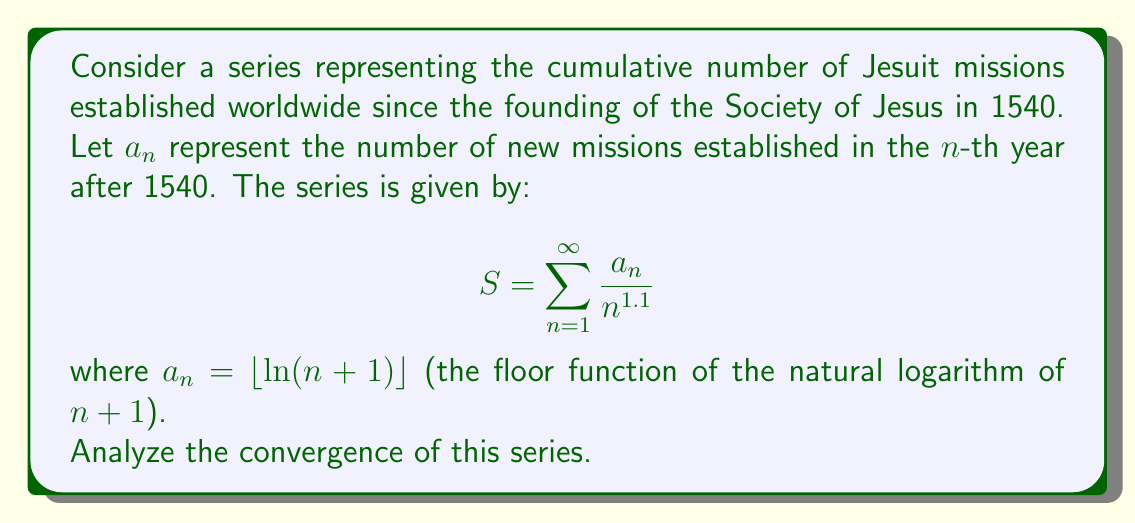Can you answer this question? To analyze the convergence of this series, we'll use the limit comparison test with a p-series.

1) First, let's examine the general term of our series:

   $\frac{a_n}{n^{1.1}} = \frac{\lfloor \ln(n+1) \rfloor}{n^{1.1}}$

2) We know that $\lfloor \ln(n+1) \rfloor \leq \ln(n+1)$ for all $n$.

3) Let's compare our series with the series $\sum \frac{\ln(n+1)}{n^{1.1}}$:

   $\lim_{n \to \infty} \frac{\frac{\lfloor \ln(n+1) \rfloor}{n^{1.1}}}{\frac{\ln(n+1)}{n^{1.1}}} = \lim_{n \to \infty} \frac{\lfloor \ln(n+1) \rfloor}{\ln(n+1)}$

4) As $n \to \infty$, $\frac{\lfloor \ln(n+1) \rfloor}{\ln(n+1)} \to 1$, so the limit exists and is finite.

5) Therefore, our original series converges if and only if $\sum \frac{\ln(n+1)}{n^{1.1}}$ converges.

6) Now, let's compare $\sum \frac{\ln(n+1)}{n^{1.1}}$ with the p-series $\sum \frac{1}{n^{1.05}}$:

   $\lim_{n \to \infty} \frac{\frac{\ln(n+1)}{n^{1.1}}}{\frac{1}{n^{1.05}}} = \lim_{n \to \infty} \frac{\ln(n+1)}{n^{0.05}}$

7) Using L'Hôpital's rule:

   $\lim_{n \to \infty} \frac{\ln(n+1)}{n^{0.05}} = \lim_{n \to \infty} \frac{\frac{1}{n+1}}{0.05n^{-0.95}} = \lim_{n \to \infty} \frac{20n^{0.95}}{n+1} = 0$

8) Since this limit is 0, $\sum \frac{\ln(n+1)}{n^{1.1}}$ converges.

9) Therefore, our original series $\sum \frac{a_n}{n^{1.1}}$ also converges.
Answer: The series $\sum_{n=1}^{\infty} \frac{a_n}{n^{1.1}}$, where $a_n = \lfloor \ln(n+1) \rfloor$, converges. 